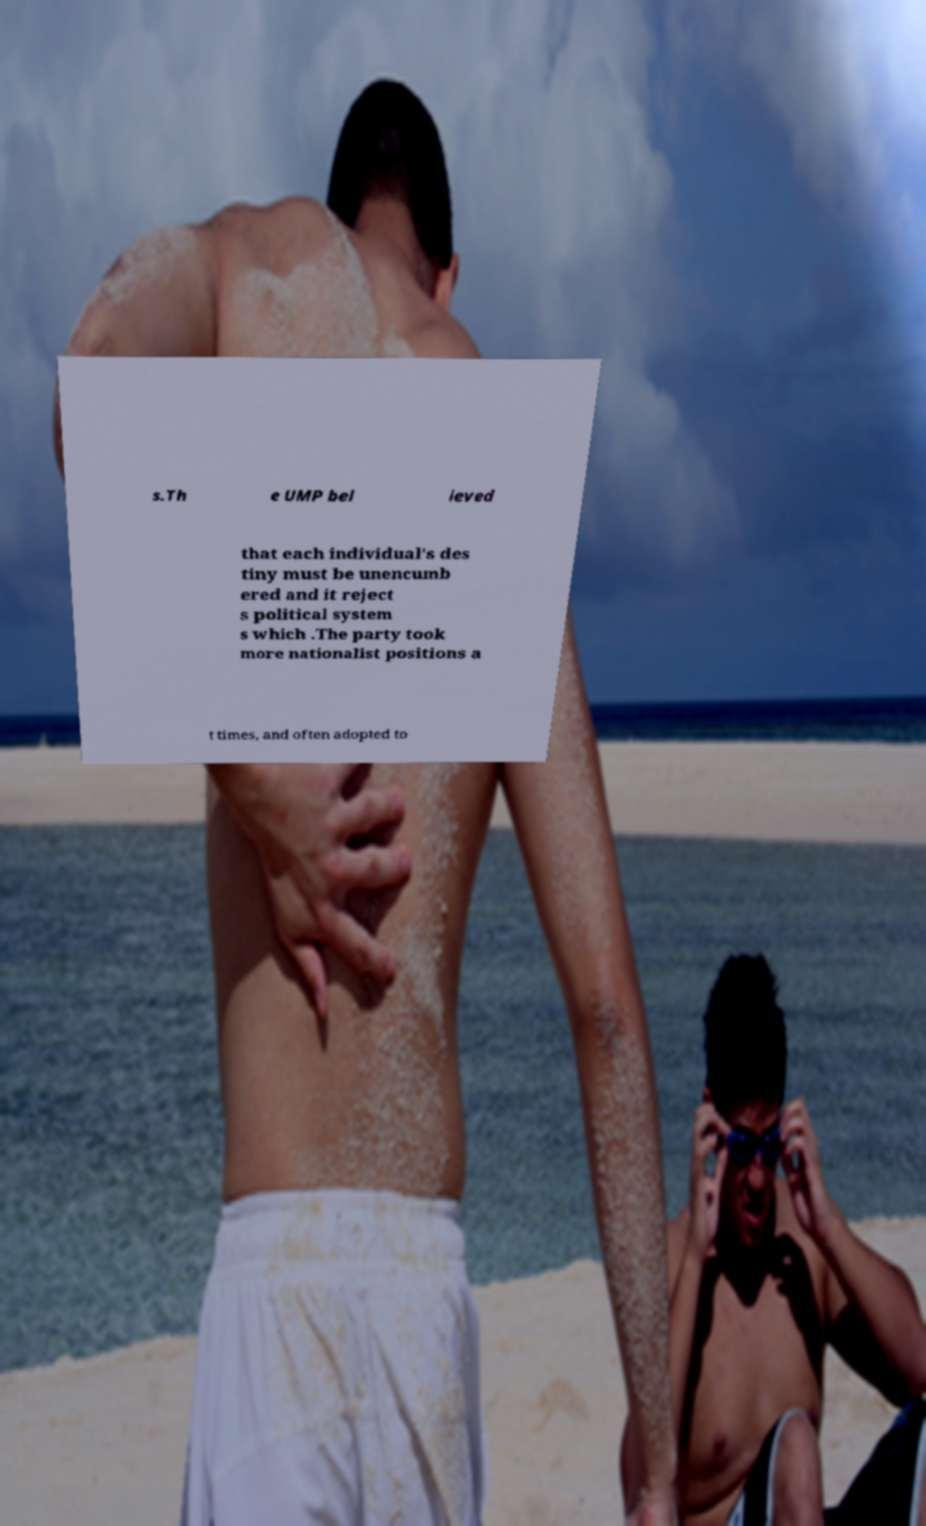What messages or text are displayed in this image? I need them in a readable, typed format. s.Th e UMP bel ieved that each individual's des tiny must be unencumb ered and it reject s political system s which .The party took more nationalist positions a t times, and often adopted to 